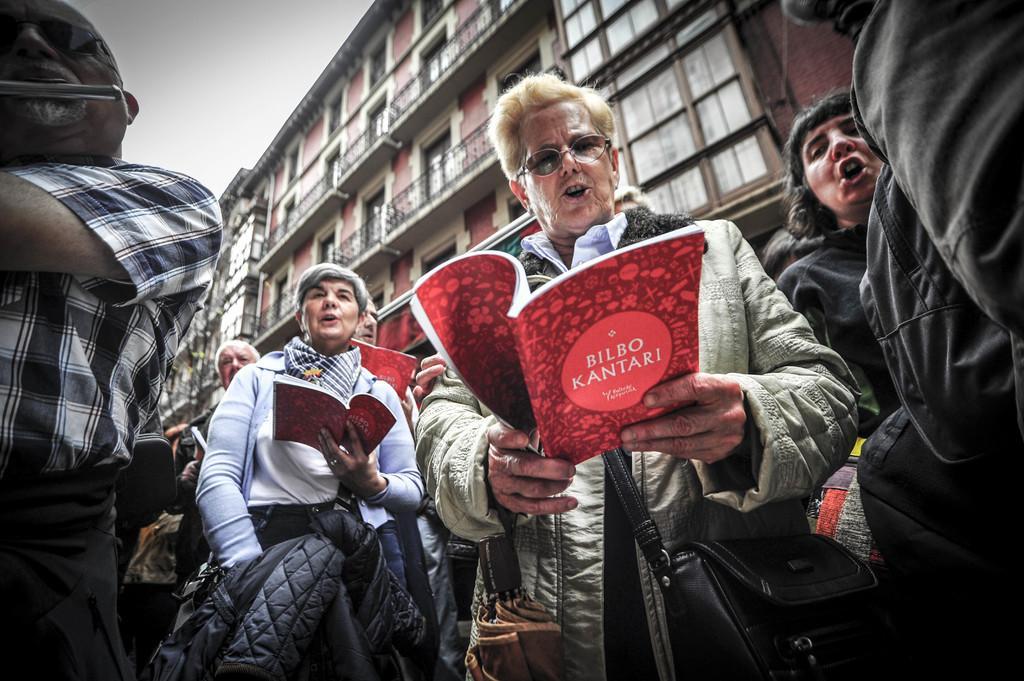Can you describe this image briefly? In this image there is a man in the middle who is holding the book. Beside him there are few other people who are holding the books. In the background there is a tall building. At the top there is the sky. 